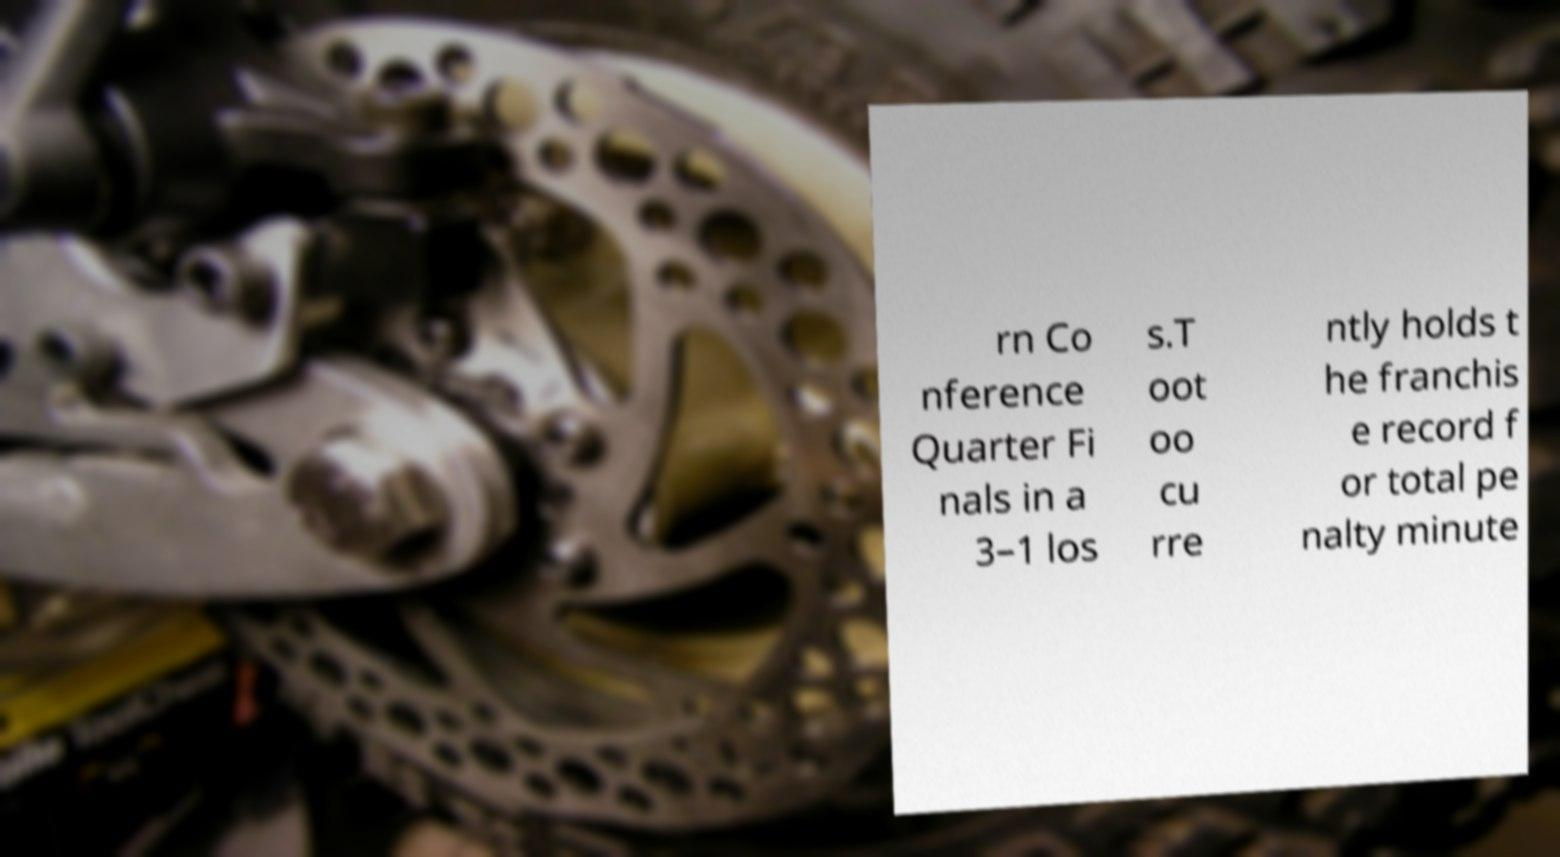Can you accurately transcribe the text from the provided image for me? rn Co nference Quarter Fi nals in a 3–1 los s.T oot oo cu rre ntly holds t he franchis e record f or total pe nalty minute 